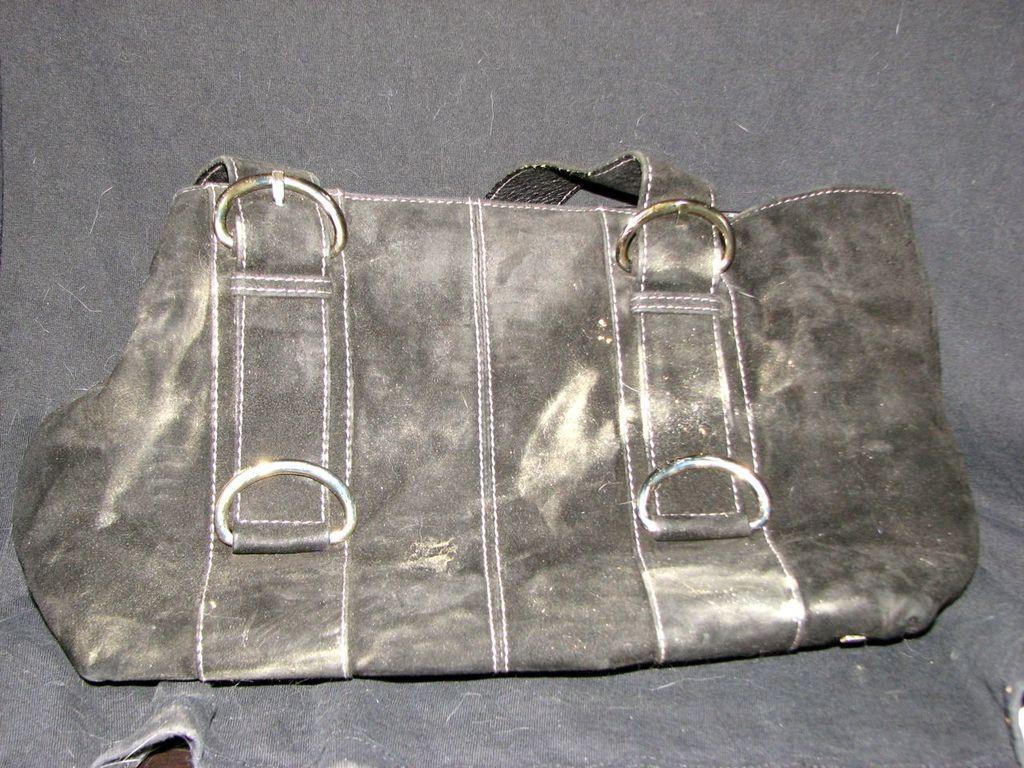What object can be seen in the image? There is a bag in the image. Can you see any airplanes taking off at the airport in the image? There is no airport or airplane visible in the image; it only features a bag. What type of powder is being used to stretch the bag in the image? There is no powder or stretching activity present in the image; it only features a bag. 